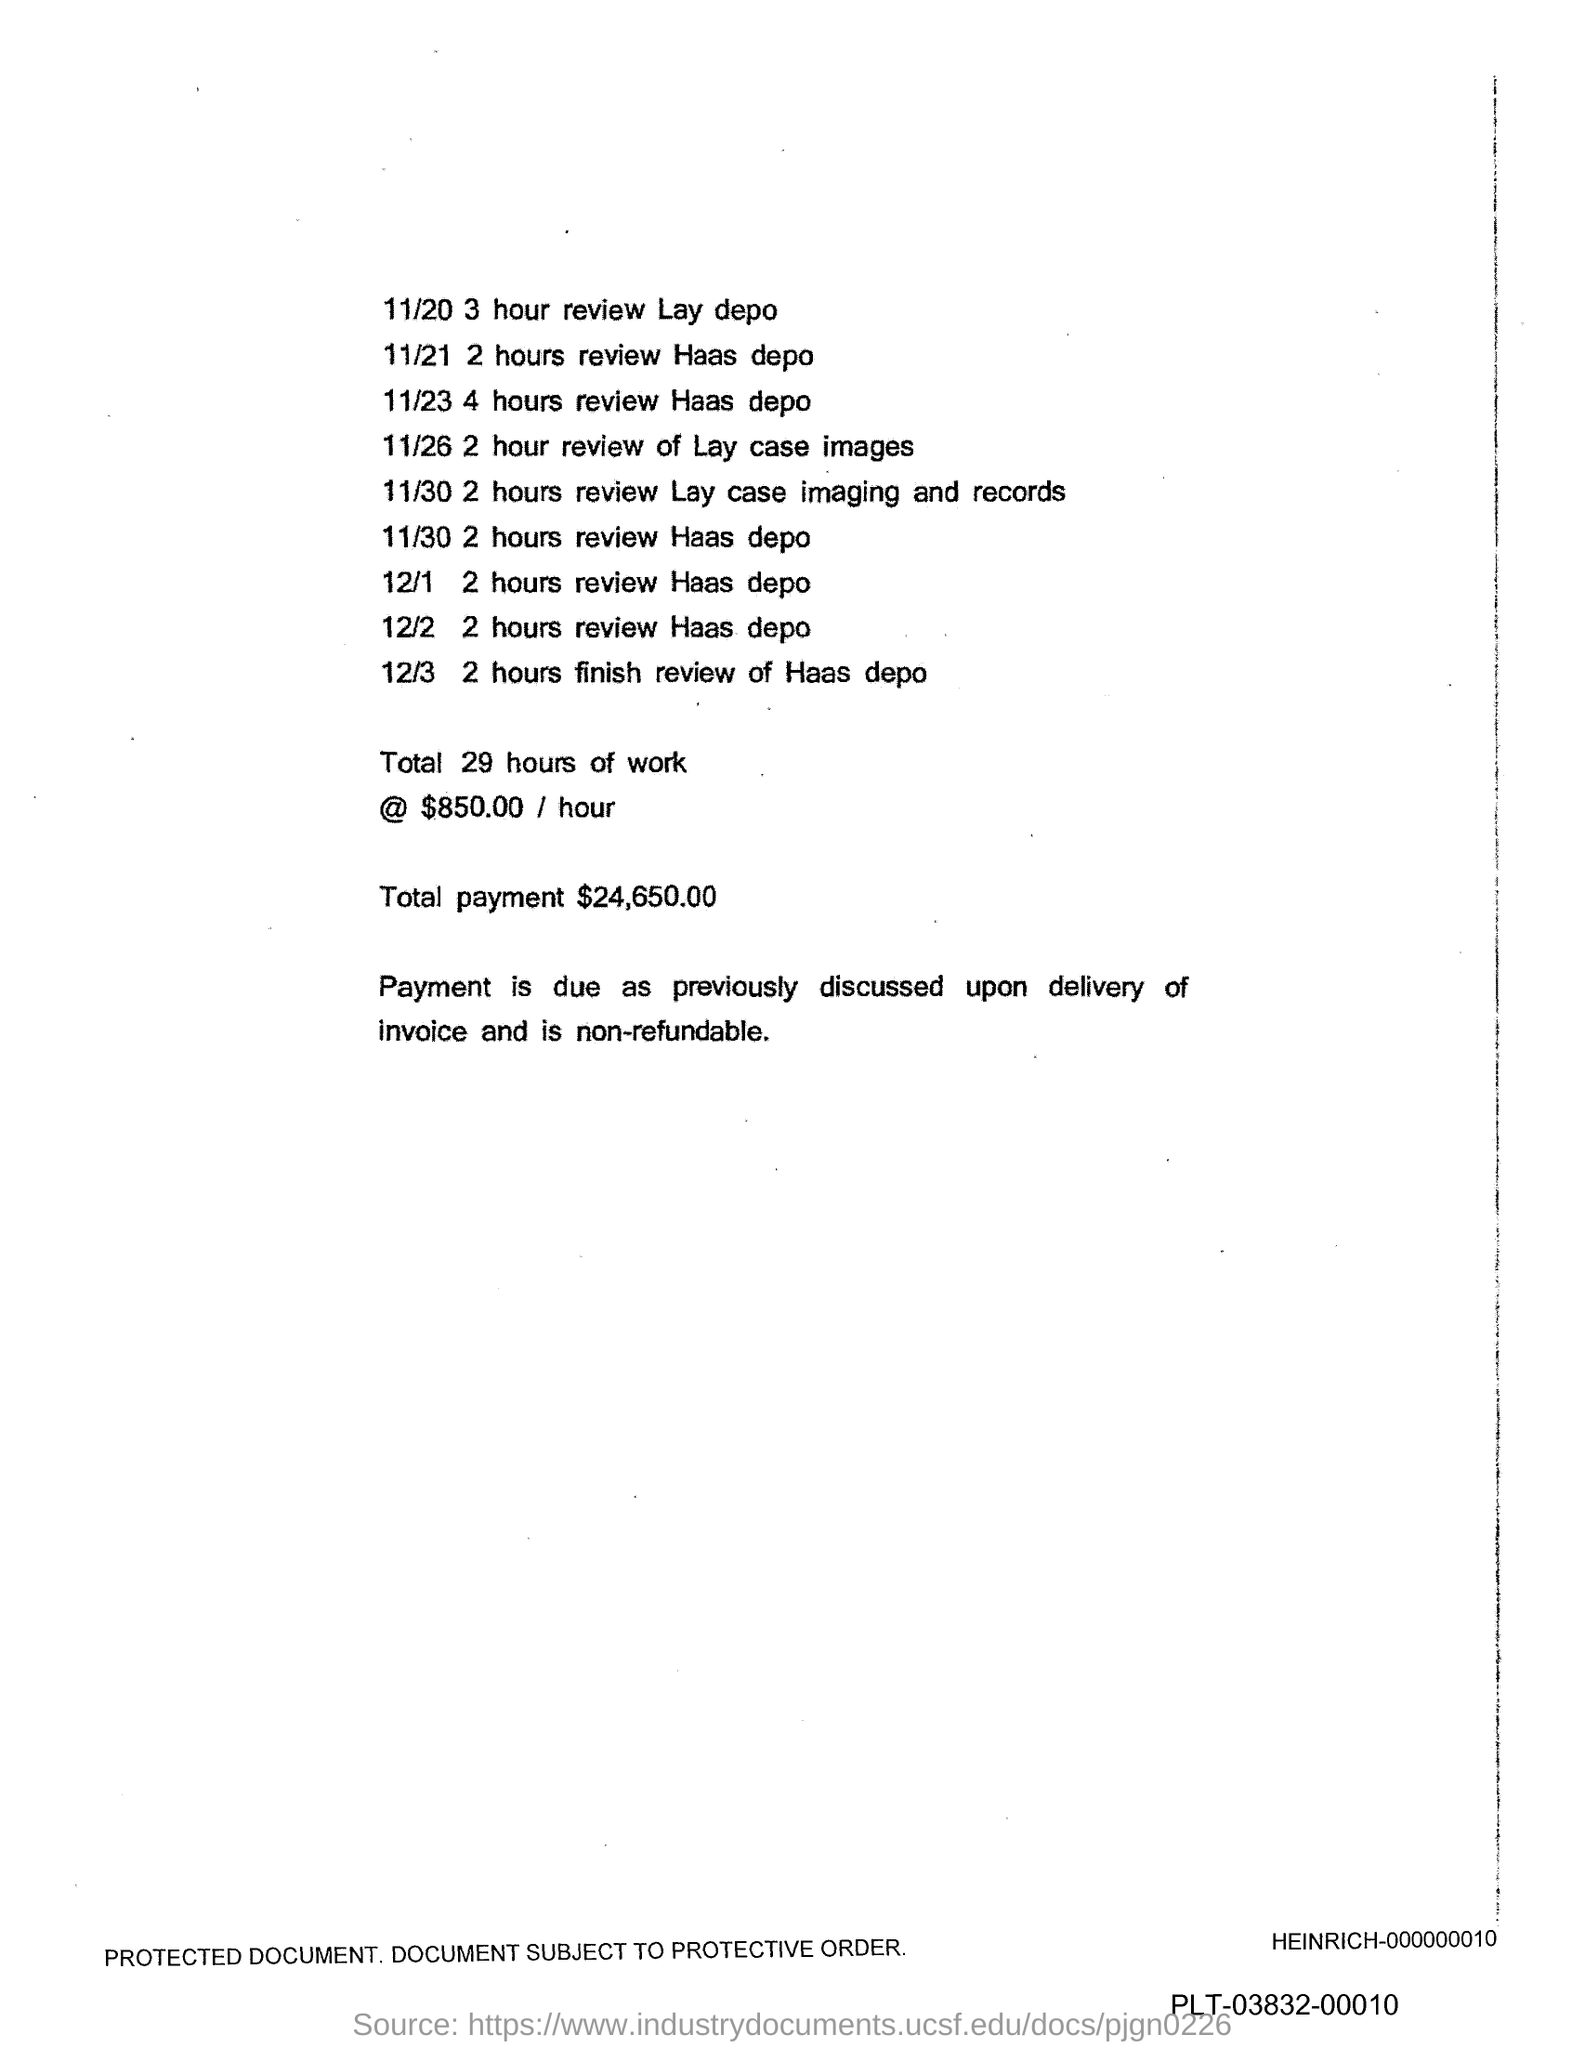Point out several critical features in this image. The total payment is $24,650.00. 